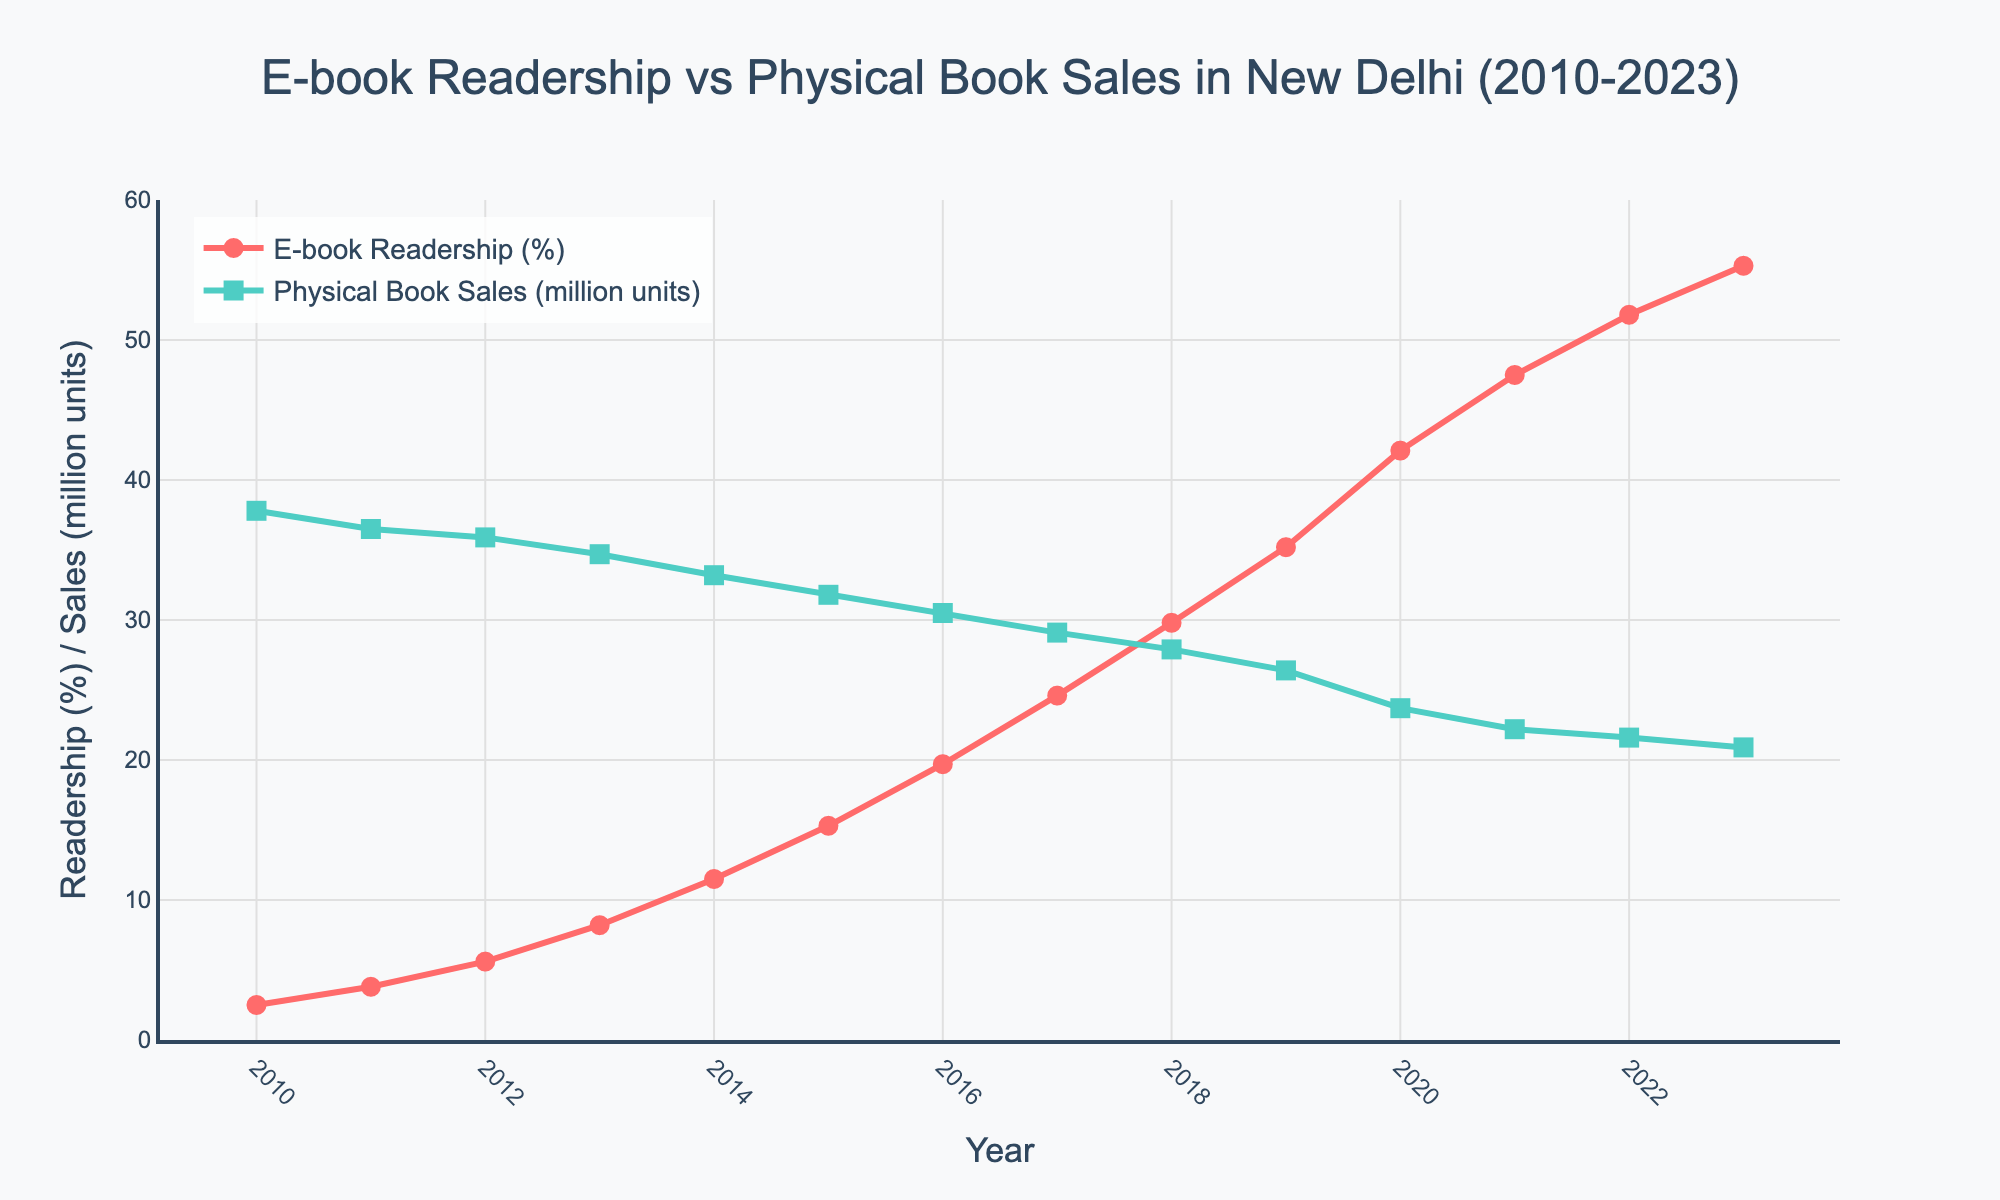What year did e-book readership surpass 20%? Observing the figure, e-book readership surpassed 20% in the year 2016 as the line for e-book readership in 2016 is slightly above the 20% mark.
Answer: 2016 Between which years did physical book sales drop the most? From 2019 to 2020, physical book sales decreased significantly from 26.4 million units to 23.7 million units, which is a drop of 2.7 million units, the largest decrease in any year range shown.
Answer: 2019 to 2020 What is the difference in e-book readership percentages between 2010 and 2023? In 2010, e-book readership was 2.5%, and in 2023, it was 55.3%, making the difference 55.3 - 2.5 = 52.8%.
Answer: 52.8% In which year was the gap between e-book readership and physical book sales the largest? The largest gap between e-book readership and physical book sales occurred in 2023 when e-book readership was at 55.3% and physical book sales were at 20.9 million units, with a significant visual gap on the figure.
Answer: 2023 What is the combined value of e-book readership percentage and physical book sales in 2014? In 2014, e-book readership was 11.5%, and physical book sales were 33.2 million units. Combined, this makes 11.5 + 33.2 = 44.7.
Answer: 44.7 How did the trends in e-book readership and physical book sales visually differ after 2013? After 2013, the e-book readership line shows a steeper upward trend, while the physical book sales line exhibits a consistent downward trend. This indicates that e-book readership increased significantly, while physical book sales steadily decreased.
Answer: increasing e-book readership, decreasing physical book sales Around what year did e-book readership reach approximately 50%? Observing the figure, e-book readership reached approximately 50% around the year 2022.
Answer: 2022 How many years did it take for e-book readership to grow from 2.5% to over 50%? E-book readership started at 2.5% in 2010 and surpassed 50% by 2022, taking about 12 years.
Answer: 12 years Compare the physical book sales values in the years 2010 and 2023. In 2010, physical book sales were at 37.8 million units, and in 2023, they dropped to 20.9 million units. Therefore, sales declined by 37.8 - 20.9 = 16.9 million units over the period.
Answer: Declined by 16.9 million units What was the average e-book readership percentage from 2010 to 2023? Summing up the e-book readership percentages from 2010 to 2023 and then dividing by the number of years: (2.5 + 3.8 + 5.6 + 8.2 + 11.5 + 15.3 + 19.7 + 24.6 + 29.8 + 35.2 + 42.1 + 47.5 + 51.8 + 55.3) / 14 = 24.64%.
Answer: 24.64% 